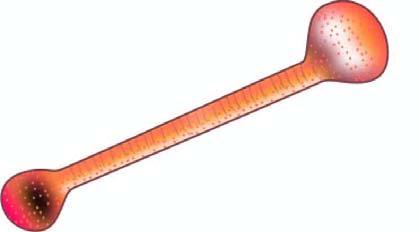s an asbestos body an asbestos fibre coated with glycoprotein and haemosiderin giving it beaded or dumbbell-shaped appearance with bulbous ends?
Answer the question using a single word or phrase. Yes 